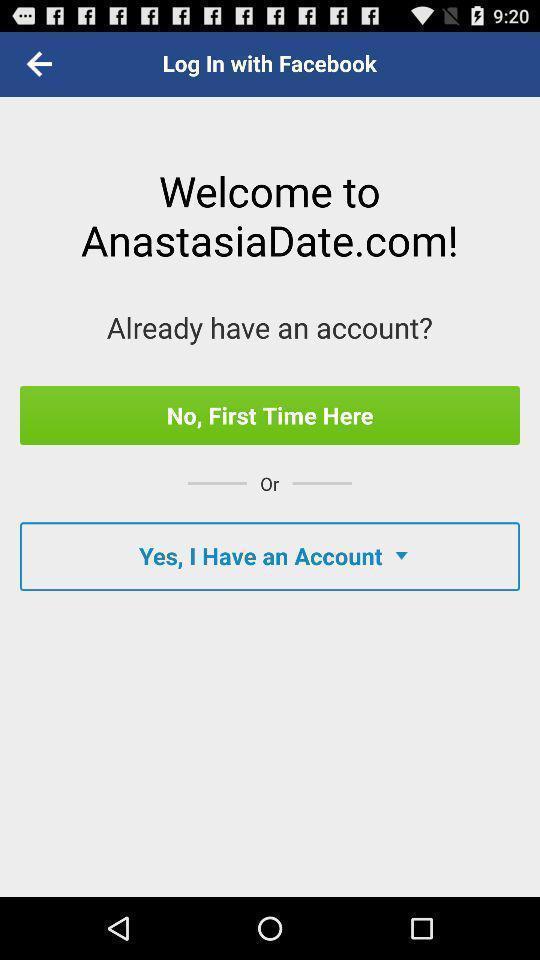Describe the content in this image. Welcome page of dating application. 